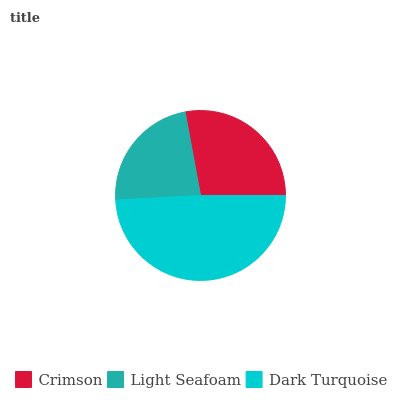Is Light Seafoam the minimum?
Answer yes or no. Yes. Is Dark Turquoise the maximum?
Answer yes or no. Yes. Is Dark Turquoise the minimum?
Answer yes or no. No. Is Light Seafoam the maximum?
Answer yes or no. No. Is Dark Turquoise greater than Light Seafoam?
Answer yes or no. Yes. Is Light Seafoam less than Dark Turquoise?
Answer yes or no. Yes. Is Light Seafoam greater than Dark Turquoise?
Answer yes or no. No. Is Dark Turquoise less than Light Seafoam?
Answer yes or no. No. Is Crimson the high median?
Answer yes or no. Yes. Is Crimson the low median?
Answer yes or no. Yes. Is Dark Turquoise the high median?
Answer yes or no. No. Is Light Seafoam the low median?
Answer yes or no. No. 